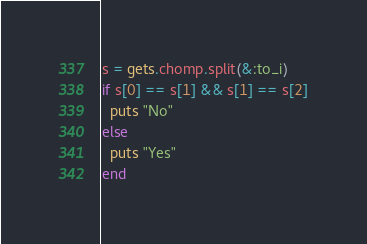Convert code to text. <code><loc_0><loc_0><loc_500><loc_500><_Ruby_>s = gets.chomp.split(&:to_i)
if s[0] == s[1] && s[1] == s[2]
  puts "No"
else
  puts "Yes"
end</code> 